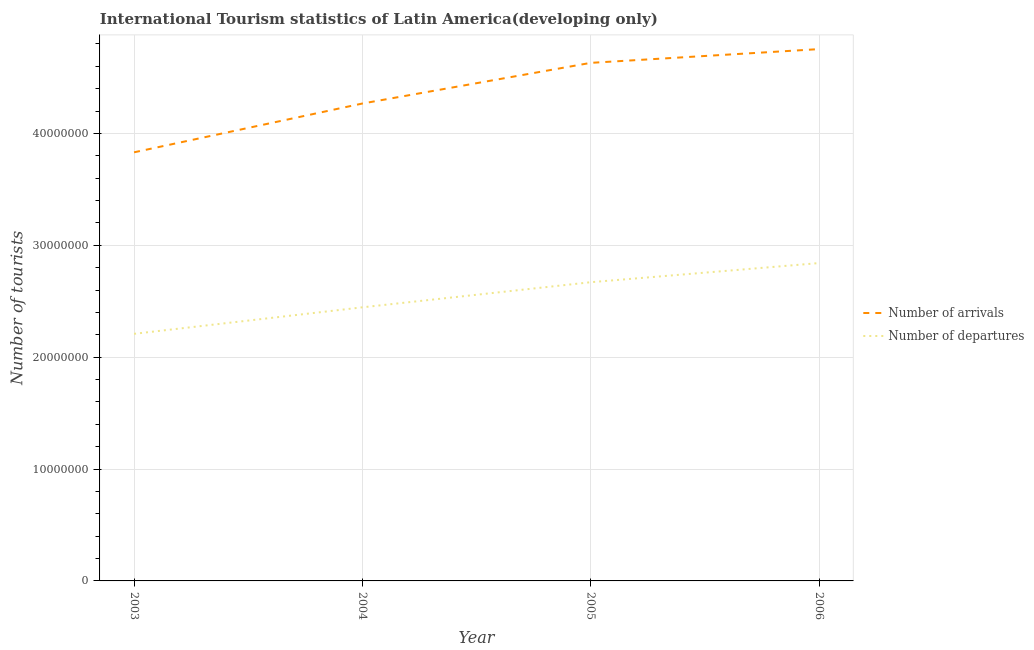How many different coloured lines are there?
Your answer should be very brief. 2. Does the line corresponding to number of tourist arrivals intersect with the line corresponding to number of tourist departures?
Ensure brevity in your answer.  No. Is the number of lines equal to the number of legend labels?
Your response must be concise. Yes. What is the number of tourist arrivals in 2005?
Offer a terse response. 4.63e+07. Across all years, what is the maximum number of tourist departures?
Provide a succinct answer. 2.84e+07. Across all years, what is the minimum number of tourist departures?
Your answer should be compact. 2.21e+07. What is the total number of tourist arrivals in the graph?
Make the answer very short. 1.75e+08. What is the difference between the number of tourist arrivals in 2003 and that in 2005?
Keep it short and to the point. -8.00e+06. What is the difference between the number of tourist arrivals in 2006 and the number of tourist departures in 2005?
Your answer should be compact. 2.08e+07. What is the average number of tourist departures per year?
Offer a terse response. 2.54e+07. In the year 2005, what is the difference between the number of tourist departures and number of tourist arrivals?
Provide a succinct answer. -1.96e+07. In how many years, is the number of tourist departures greater than 12000000?
Give a very brief answer. 4. What is the ratio of the number of tourist arrivals in 2003 to that in 2004?
Your answer should be very brief. 0.9. Is the difference between the number of tourist departures in 2005 and 2006 greater than the difference between the number of tourist arrivals in 2005 and 2006?
Provide a short and direct response. No. What is the difference between the highest and the second highest number of tourist arrivals?
Your answer should be compact. 1.23e+06. What is the difference between the highest and the lowest number of tourist departures?
Provide a succinct answer. 6.33e+06. In how many years, is the number of tourist departures greater than the average number of tourist departures taken over all years?
Provide a short and direct response. 2. Does the number of tourist arrivals monotonically increase over the years?
Your response must be concise. Yes. Is the number of tourist departures strictly less than the number of tourist arrivals over the years?
Provide a short and direct response. Yes. Does the graph contain any zero values?
Your answer should be very brief. No. Where does the legend appear in the graph?
Ensure brevity in your answer.  Center right. How many legend labels are there?
Your answer should be compact. 2. How are the legend labels stacked?
Your response must be concise. Vertical. What is the title of the graph?
Provide a short and direct response. International Tourism statistics of Latin America(developing only). What is the label or title of the Y-axis?
Your response must be concise. Number of tourists. What is the Number of tourists of Number of arrivals in 2003?
Keep it short and to the point. 3.83e+07. What is the Number of tourists of Number of departures in 2003?
Your answer should be very brief. 2.21e+07. What is the Number of tourists of Number of arrivals in 2004?
Give a very brief answer. 4.27e+07. What is the Number of tourists in Number of departures in 2004?
Provide a succinct answer. 2.45e+07. What is the Number of tourists of Number of arrivals in 2005?
Ensure brevity in your answer.  4.63e+07. What is the Number of tourists of Number of departures in 2005?
Offer a terse response. 2.67e+07. What is the Number of tourists in Number of arrivals in 2006?
Keep it short and to the point. 4.75e+07. What is the Number of tourists in Number of departures in 2006?
Your response must be concise. 2.84e+07. Across all years, what is the maximum Number of tourists of Number of arrivals?
Offer a very short reply. 4.75e+07. Across all years, what is the maximum Number of tourists of Number of departures?
Give a very brief answer. 2.84e+07. Across all years, what is the minimum Number of tourists of Number of arrivals?
Give a very brief answer. 3.83e+07. Across all years, what is the minimum Number of tourists in Number of departures?
Give a very brief answer. 2.21e+07. What is the total Number of tourists of Number of arrivals in the graph?
Provide a short and direct response. 1.75e+08. What is the total Number of tourists in Number of departures in the graph?
Ensure brevity in your answer.  1.02e+08. What is the difference between the Number of tourists of Number of arrivals in 2003 and that in 2004?
Your answer should be very brief. -4.36e+06. What is the difference between the Number of tourists in Number of departures in 2003 and that in 2004?
Provide a succinct answer. -2.37e+06. What is the difference between the Number of tourists in Number of arrivals in 2003 and that in 2005?
Your response must be concise. -8.00e+06. What is the difference between the Number of tourists in Number of departures in 2003 and that in 2005?
Keep it short and to the point. -4.61e+06. What is the difference between the Number of tourists of Number of arrivals in 2003 and that in 2006?
Offer a terse response. -9.23e+06. What is the difference between the Number of tourists in Number of departures in 2003 and that in 2006?
Give a very brief answer. -6.33e+06. What is the difference between the Number of tourists of Number of arrivals in 2004 and that in 2005?
Provide a succinct answer. -3.63e+06. What is the difference between the Number of tourists in Number of departures in 2004 and that in 2005?
Provide a succinct answer. -2.24e+06. What is the difference between the Number of tourists in Number of arrivals in 2004 and that in 2006?
Your response must be concise. -4.86e+06. What is the difference between the Number of tourists in Number of departures in 2004 and that in 2006?
Keep it short and to the point. -3.96e+06. What is the difference between the Number of tourists in Number of arrivals in 2005 and that in 2006?
Make the answer very short. -1.23e+06. What is the difference between the Number of tourists of Number of departures in 2005 and that in 2006?
Offer a very short reply. -1.71e+06. What is the difference between the Number of tourists of Number of arrivals in 2003 and the Number of tourists of Number of departures in 2004?
Your response must be concise. 1.39e+07. What is the difference between the Number of tourists of Number of arrivals in 2003 and the Number of tourists of Number of departures in 2005?
Give a very brief answer. 1.16e+07. What is the difference between the Number of tourists of Number of arrivals in 2003 and the Number of tourists of Number of departures in 2006?
Offer a very short reply. 9.90e+06. What is the difference between the Number of tourists in Number of arrivals in 2004 and the Number of tourists in Number of departures in 2005?
Provide a succinct answer. 1.60e+07. What is the difference between the Number of tourists of Number of arrivals in 2004 and the Number of tourists of Number of departures in 2006?
Offer a very short reply. 1.43e+07. What is the difference between the Number of tourists of Number of arrivals in 2005 and the Number of tourists of Number of departures in 2006?
Keep it short and to the point. 1.79e+07. What is the average Number of tourists in Number of arrivals per year?
Your response must be concise. 4.37e+07. What is the average Number of tourists in Number of departures per year?
Make the answer very short. 2.54e+07. In the year 2003, what is the difference between the Number of tourists of Number of arrivals and Number of tourists of Number of departures?
Give a very brief answer. 1.62e+07. In the year 2004, what is the difference between the Number of tourists of Number of arrivals and Number of tourists of Number of departures?
Offer a very short reply. 1.82e+07. In the year 2005, what is the difference between the Number of tourists in Number of arrivals and Number of tourists in Number of departures?
Keep it short and to the point. 1.96e+07. In the year 2006, what is the difference between the Number of tourists in Number of arrivals and Number of tourists in Number of departures?
Ensure brevity in your answer.  1.91e+07. What is the ratio of the Number of tourists of Number of arrivals in 2003 to that in 2004?
Ensure brevity in your answer.  0.9. What is the ratio of the Number of tourists of Number of departures in 2003 to that in 2004?
Provide a succinct answer. 0.9. What is the ratio of the Number of tourists of Number of arrivals in 2003 to that in 2005?
Your response must be concise. 0.83. What is the ratio of the Number of tourists of Number of departures in 2003 to that in 2005?
Your answer should be very brief. 0.83. What is the ratio of the Number of tourists in Number of arrivals in 2003 to that in 2006?
Keep it short and to the point. 0.81. What is the ratio of the Number of tourists in Number of departures in 2003 to that in 2006?
Give a very brief answer. 0.78. What is the ratio of the Number of tourists in Number of arrivals in 2004 to that in 2005?
Make the answer very short. 0.92. What is the ratio of the Number of tourists in Number of departures in 2004 to that in 2005?
Provide a succinct answer. 0.92. What is the ratio of the Number of tourists of Number of arrivals in 2004 to that in 2006?
Give a very brief answer. 0.9. What is the ratio of the Number of tourists of Number of departures in 2004 to that in 2006?
Offer a terse response. 0.86. What is the ratio of the Number of tourists of Number of arrivals in 2005 to that in 2006?
Your response must be concise. 0.97. What is the ratio of the Number of tourists in Number of departures in 2005 to that in 2006?
Ensure brevity in your answer.  0.94. What is the difference between the highest and the second highest Number of tourists of Number of arrivals?
Your answer should be compact. 1.23e+06. What is the difference between the highest and the second highest Number of tourists in Number of departures?
Make the answer very short. 1.71e+06. What is the difference between the highest and the lowest Number of tourists of Number of arrivals?
Your answer should be very brief. 9.23e+06. What is the difference between the highest and the lowest Number of tourists of Number of departures?
Provide a short and direct response. 6.33e+06. 